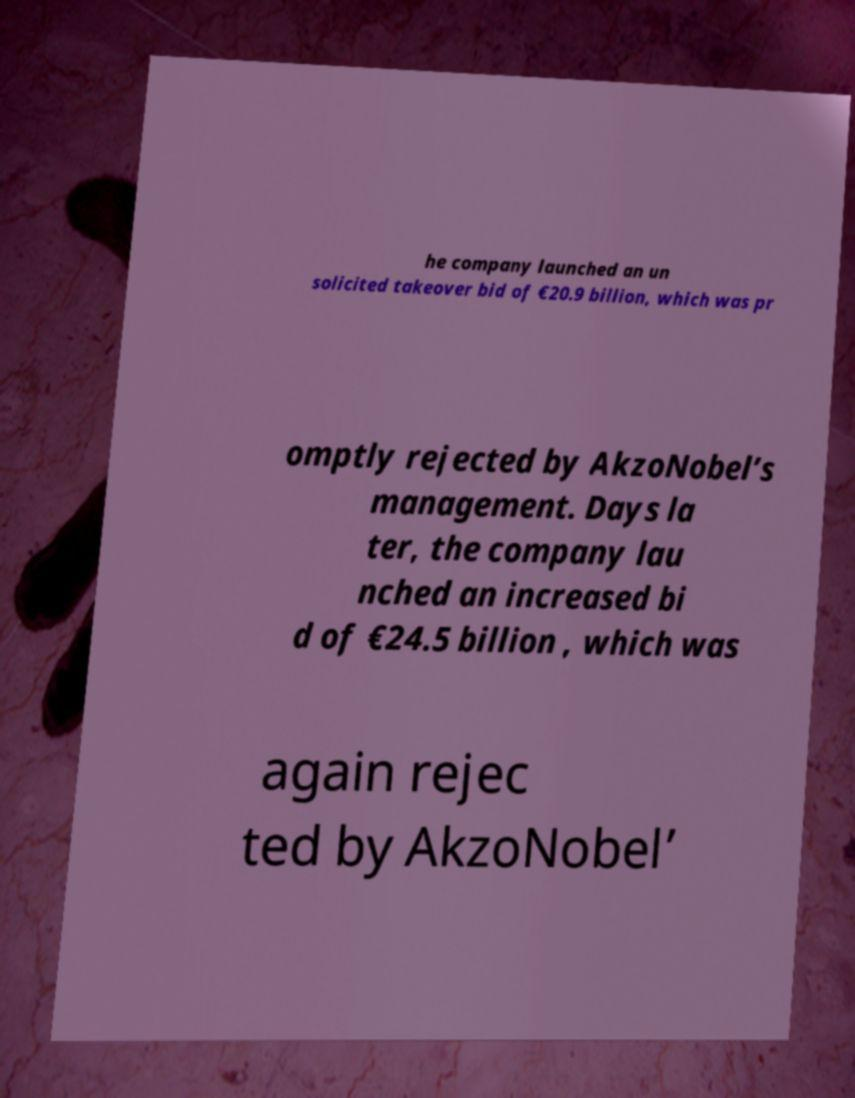Can you read and provide the text displayed in the image?This photo seems to have some interesting text. Can you extract and type it out for me? he company launched an un solicited takeover bid of €20.9 billion, which was pr omptly rejected by AkzoNobel’s management. Days la ter, the company lau nched an increased bi d of €24.5 billion , which was again rejec ted by AkzoNobel’ 